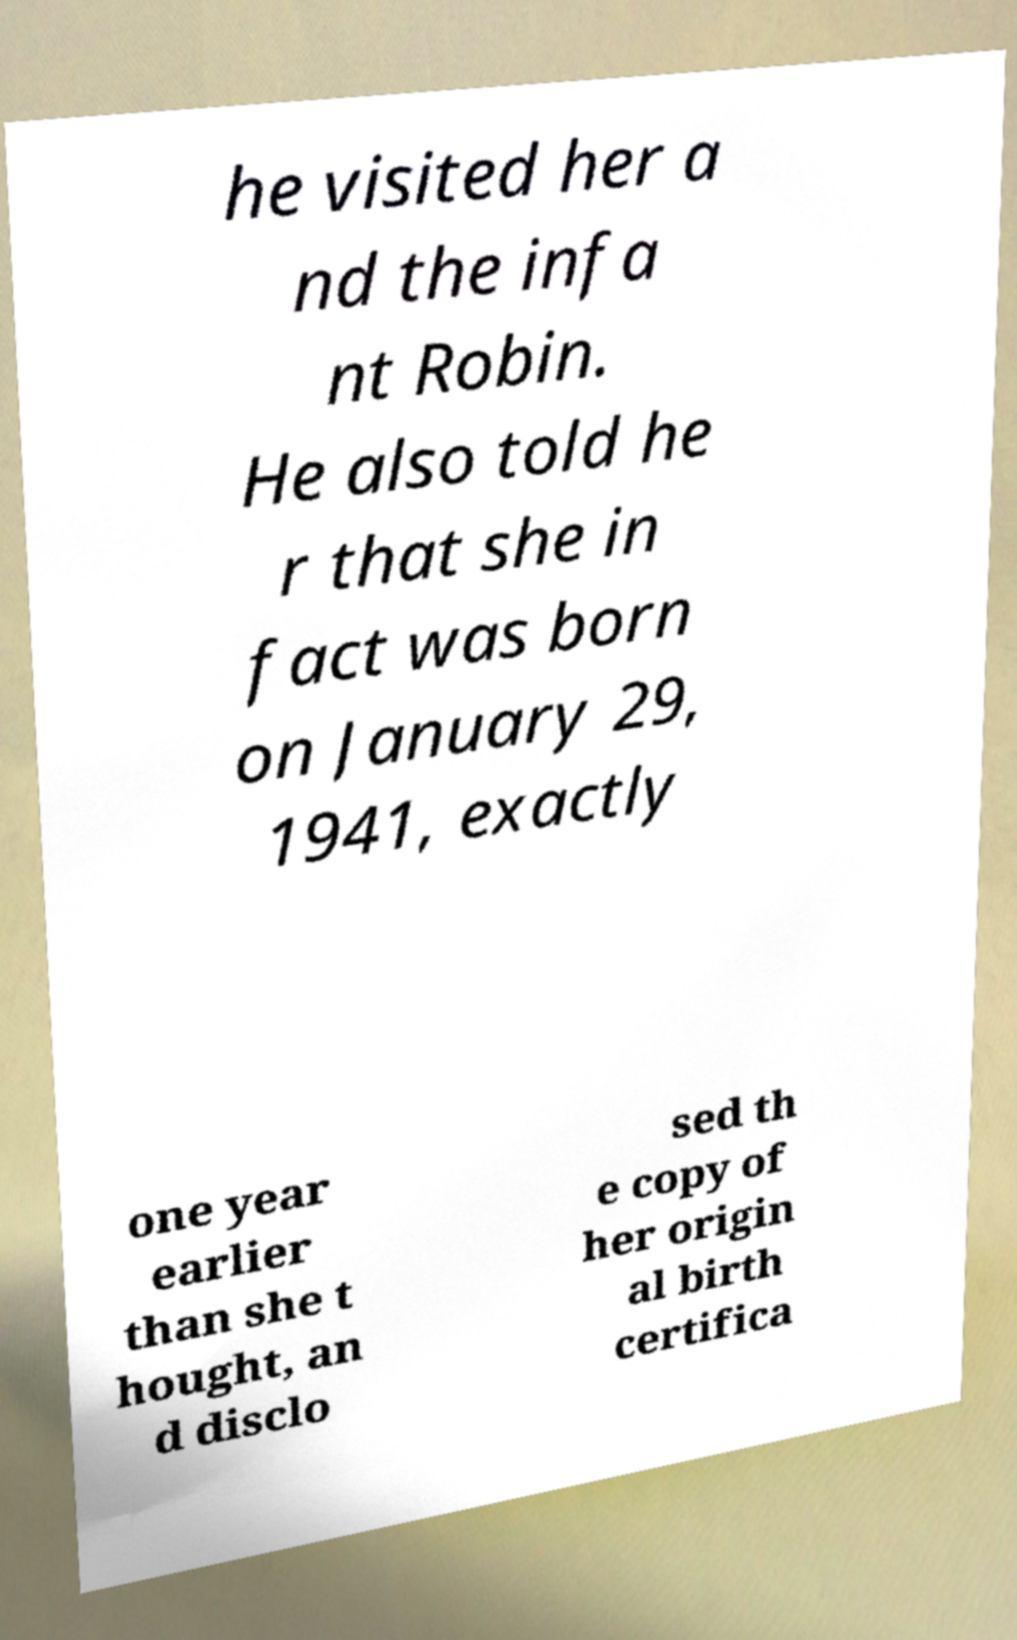Could you assist in decoding the text presented in this image and type it out clearly? he visited her a nd the infa nt Robin. He also told he r that she in fact was born on January 29, 1941, exactly one year earlier than she t hought, an d disclo sed th e copy of her origin al birth certifica 